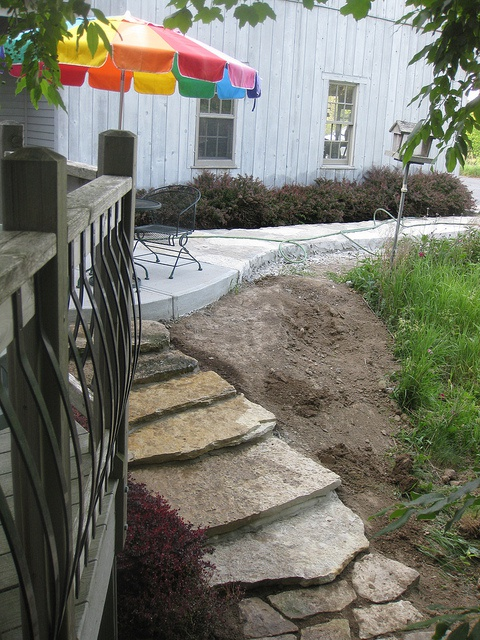Describe the objects in this image and their specific colors. I can see umbrella in darkgreen, red, ivory, orange, and lightpink tones, chair in darkgreen, black, gray, lightgray, and darkgray tones, and dining table in darkgreen, gray, black, and purple tones in this image. 